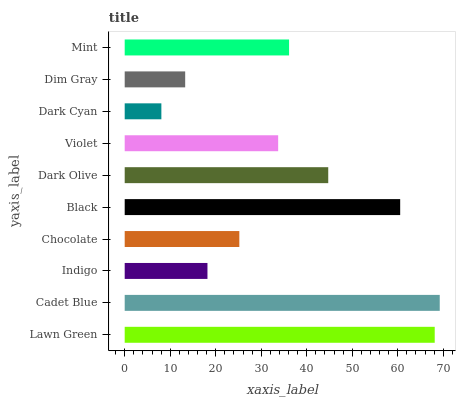Is Dark Cyan the minimum?
Answer yes or no. Yes. Is Cadet Blue the maximum?
Answer yes or no. Yes. Is Indigo the minimum?
Answer yes or no. No. Is Indigo the maximum?
Answer yes or no. No. Is Cadet Blue greater than Indigo?
Answer yes or no. Yes. Is Indigo less than Cadet Blue?
Answer yes or no. Yes. Is Indigo greater than Cadet Blue?
Answer yes or no. No. Is Cadet Blue less than Indigo?
Answer yes or no. No. Is Mint the high median?
Answer yes or no. Yes. Is Violet the low median?
Answer yes or no. Yes. Is Indigo the high median?
Answer yes or no. No. Is Black the low median?
Answer yes or no. No. 